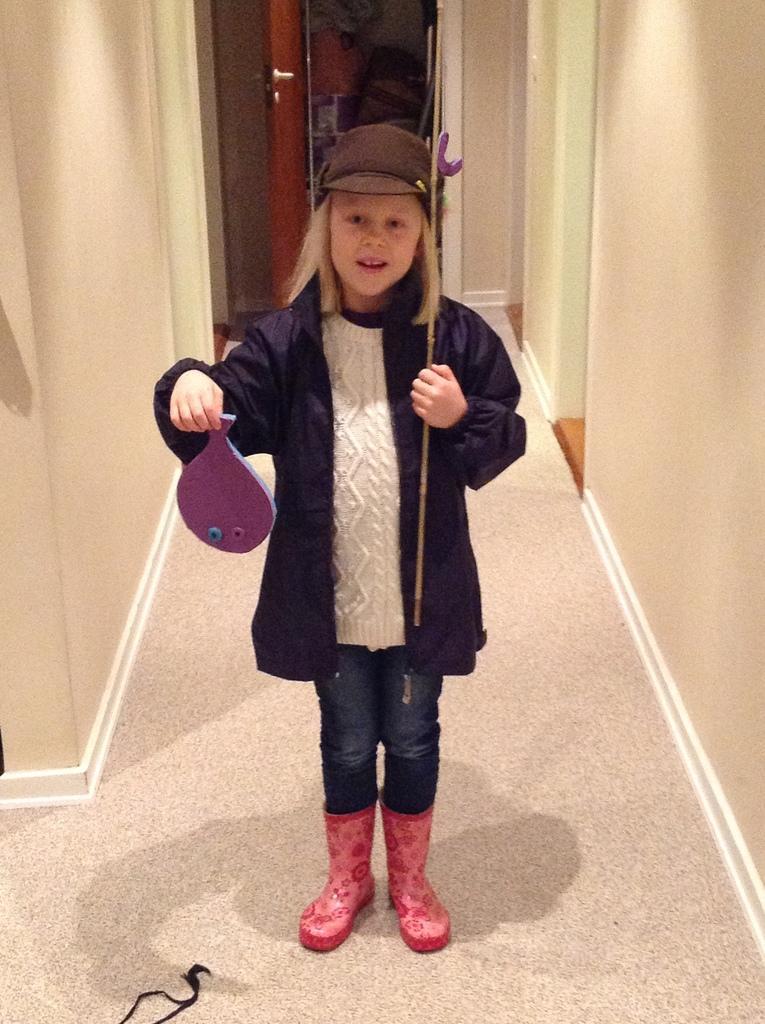Can you describe this image briefly? In this image, we can see a person holding some objects is standing. We can see the ground and the wall. We can also see some objects in the background. We can see an object on the ground. 